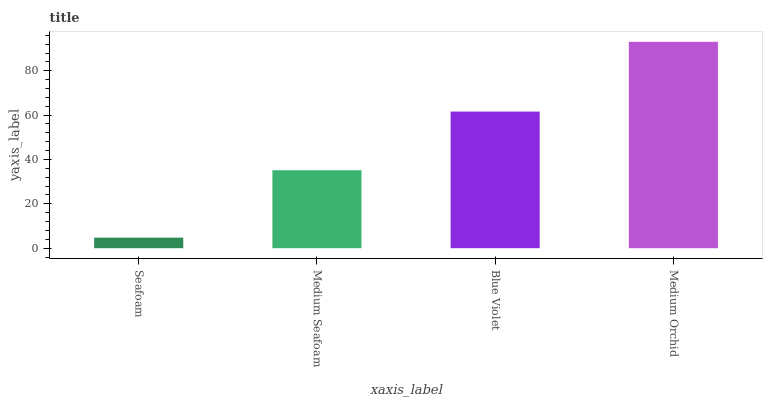Is Seafoam the minimum?
Answer yes or no. Yes. Is Medium Orchid the maximum?
Answer yes or no. Yes. Is Medium Seafoam the minimum?
Answer yes or no. No. Is Medium Seafoam the maximum?
Answer yes or no. No. Is Medium Seafoam greater than Seafoam?
Answer yes or no. Yes. Is Seafoam less than Medium Seafoam?
Answer yes or no. Yes. Is Seafoam greater than Medium Seafoam?
Answer yes or no. No. Is Medium Seafoam less than Seafoam?
Answer yes or no. No. Is Blue Violet the high median?
Answer yes or no. Yes. Is Medium Seafoam the low median?
Answer yes or no. Yes. Is Medium Seafoam the high median?
Answer yes or no. No. Is Seafoam the low median?
Answer yes or no. No. 